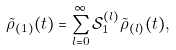Convert formula to latex. <formula><loc_0><loc_0><loc_500><loc_500>\tilde { \rho } _ { ( 1 ) } ( t ) = \sum _ { l = 0 } ^ { \infty } \mathcal { S } ^ { ( l ) } _ { 1 } \tilde { \rho } _ { ( l ) } ( t ) ,</formula> 